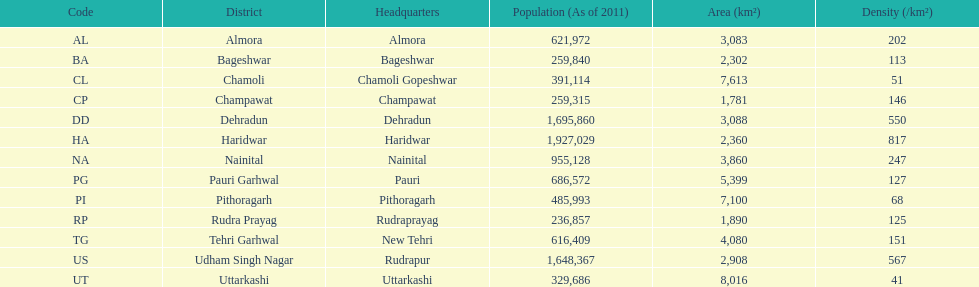What is the next most populous district after haridwar? Dehradun. 